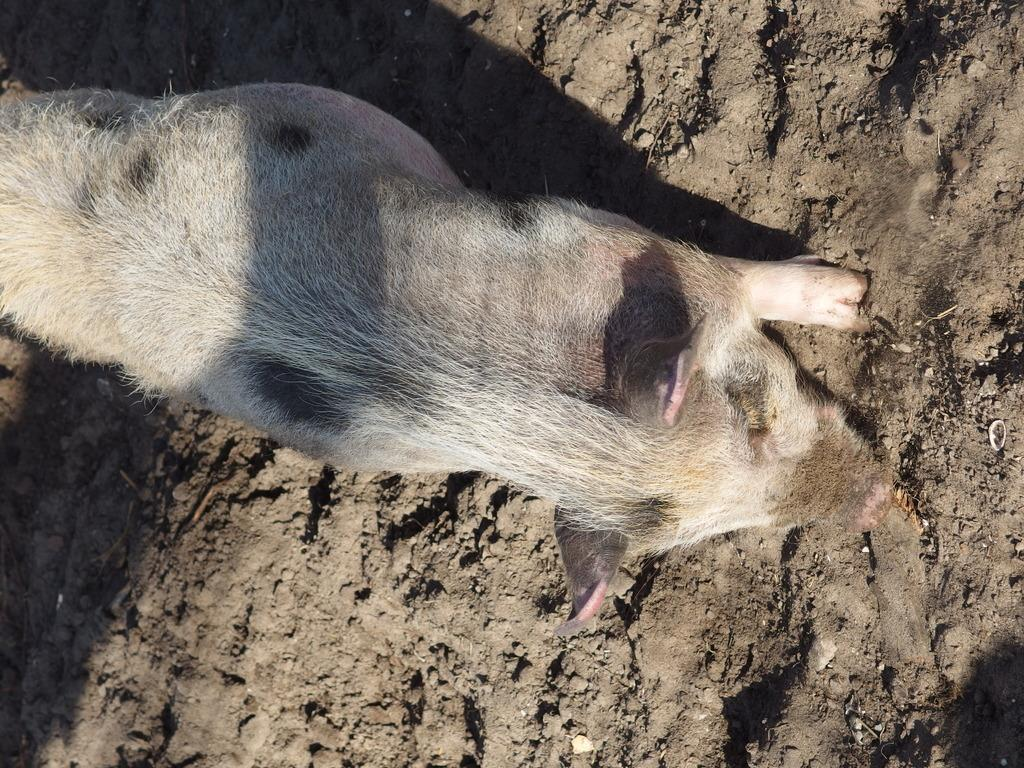What animal is in the center of the image? There is a pig in the center of the image. What can be seen in the background of the image? There is mud visible in the background of the image. What type of gun is the pig holding in the image? There is no gun present in the image; it features a pig in the center of the image with mud visible in the background. 